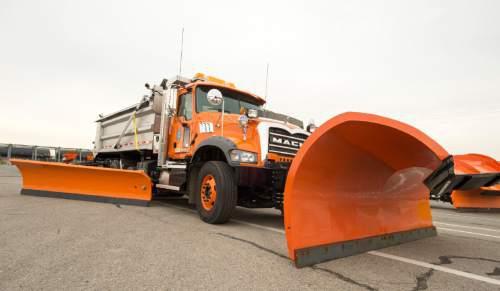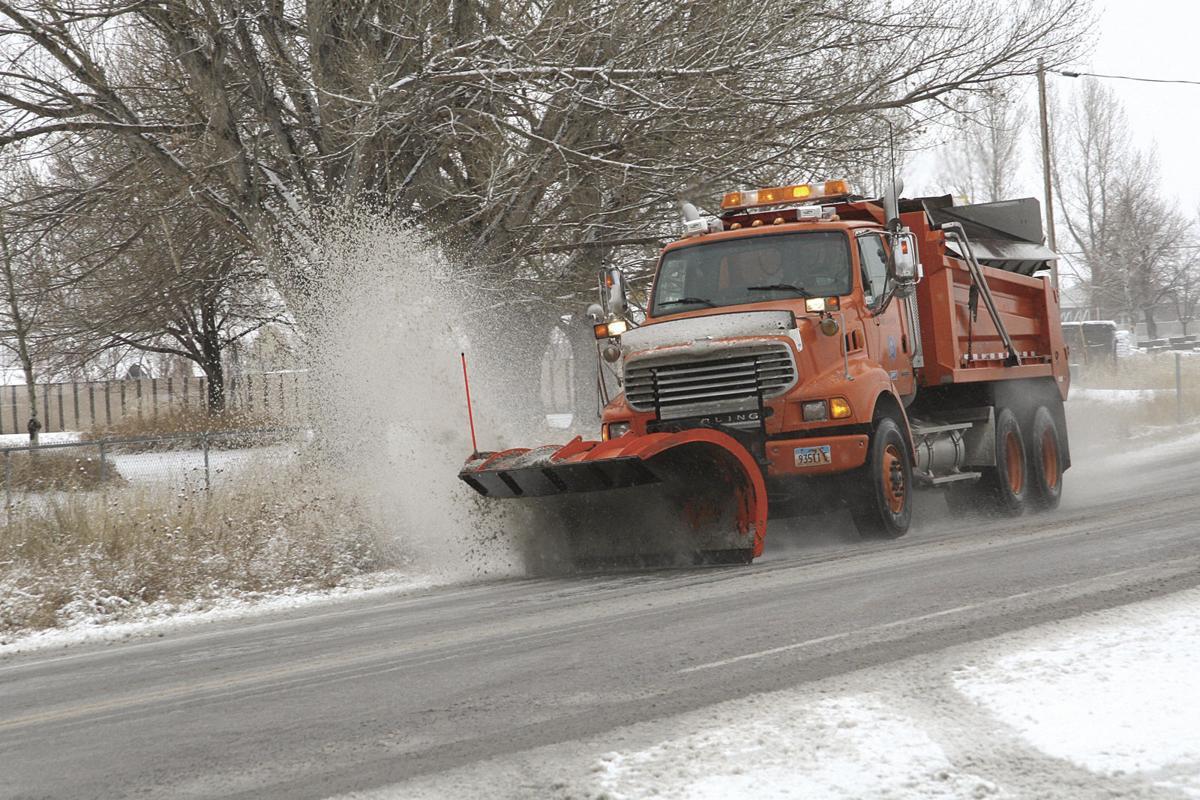The first image is the image on the left, the second image is the image on the right. Considering the images on both sides, is "The road in the image on the left is cleared of snow, while the snow is still being cleared in the image on the right." valid? Answer yes or no. Yes. The first image is the image on the left, the second image is the image on the right. Given the left and right images, does the statement "Exactly one snow plow is plowing snow." hold true? Answer yes or no. Yes. 